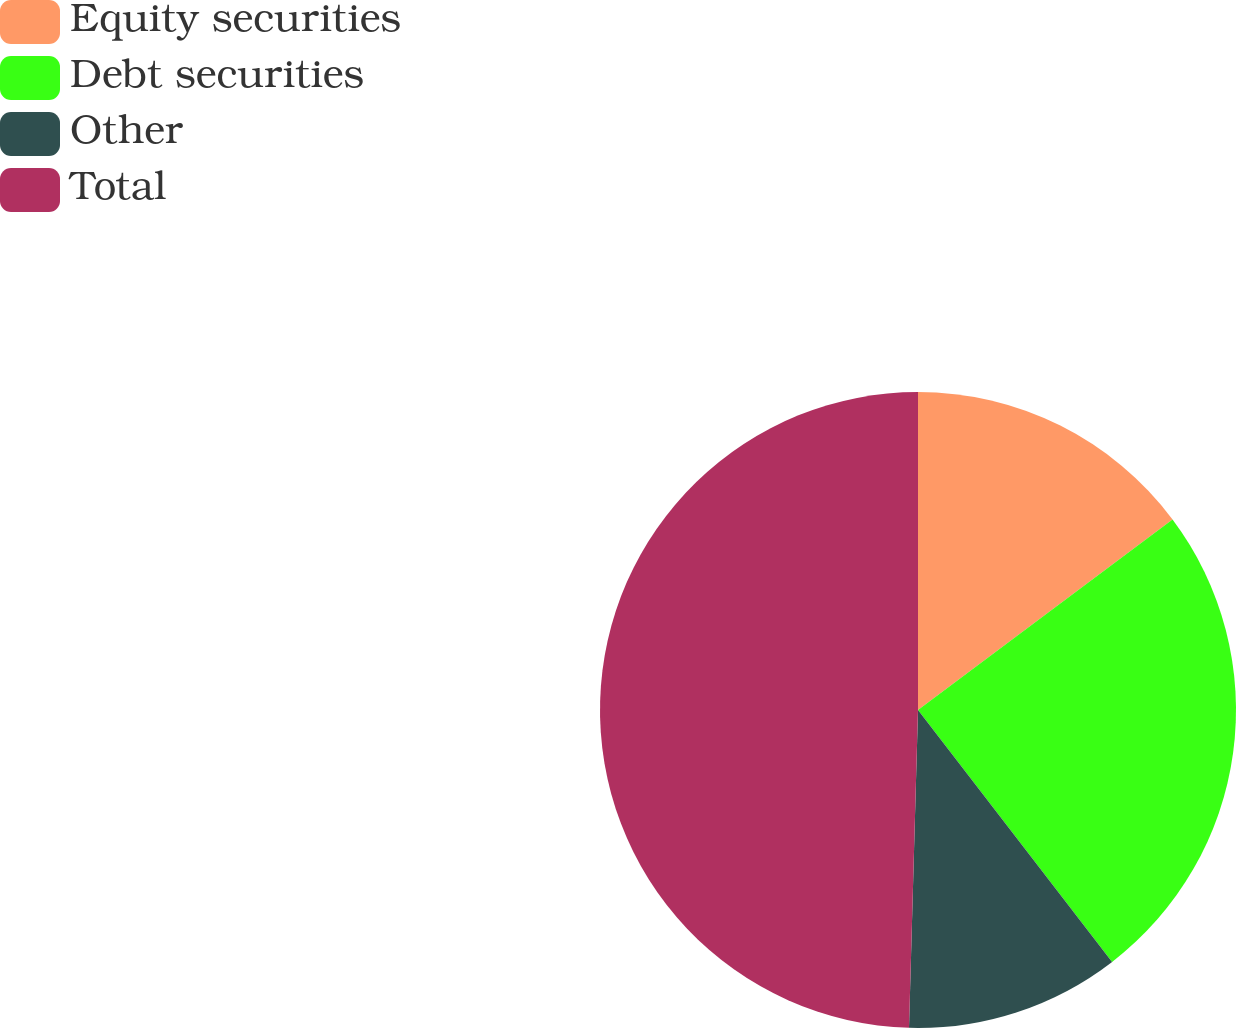Convert chart. <chart><loc_0><loc_0><loc_500><loc_500><pie_chart><fcel>Equity securities<fcel>Debt securities<fcel>Other<fcel>Total<nl><fcel>14.77%<fcel>24.78%<fcel>10.9%<fcel>49.55%<nl></chart> 